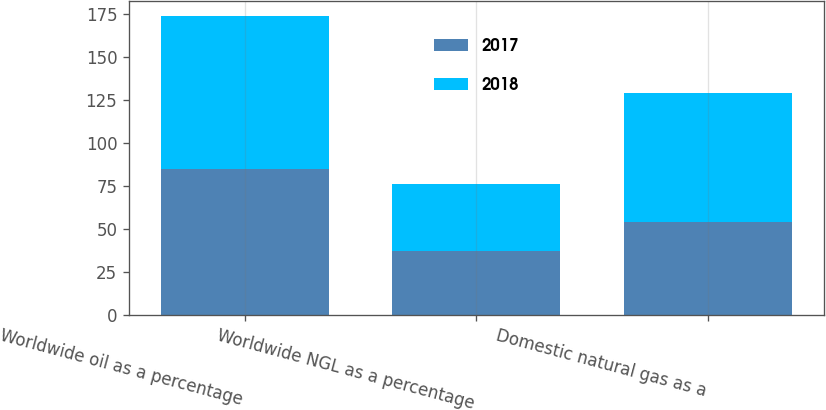Convert chart. <chart><loc_0><loc_0><loc_500><loc_500><stacked_bar_chart><ecel><fcel>Worldwide oil as a percentage<fcel>Worldwide NGL as a percentage<fcel>Domestic natural gas as a<nl><fcel>2017<fcel>85<fcel>37<fcel>54<nl><fcel>2018<fcel>89<fcel>39<fcel>75<nl></chart> 